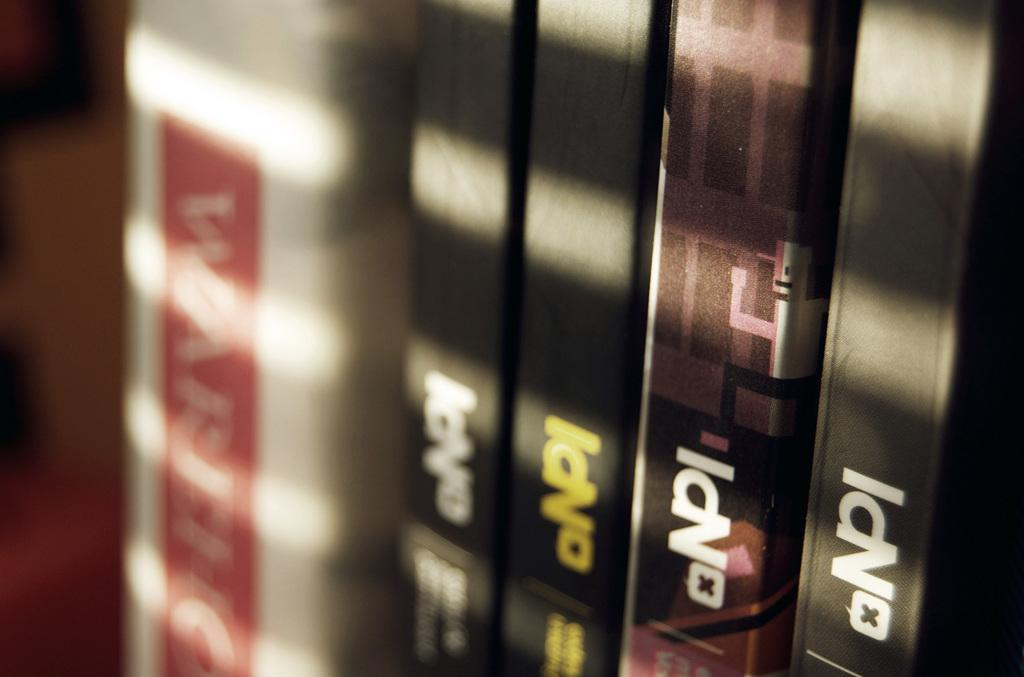<image>
Share a concise interpretation of the image provided. several books are sitting side by side that say NpI 